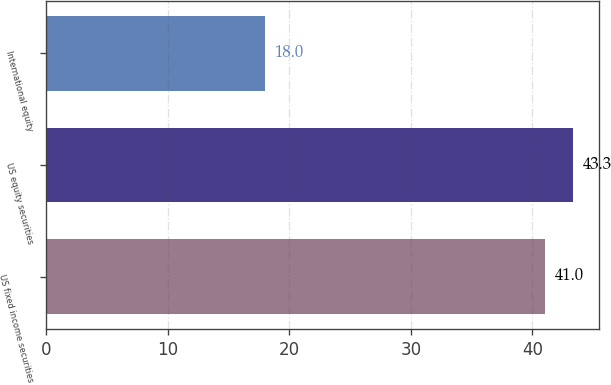<chart> <loc_0><loc_0><loc_500><loc_500><bar_chart><fcel>US fixed income securities<fcel>US equity securities<fcel>International equity<nl><fcel>41<fcel>43.3<fcel>18<nl></chart> 